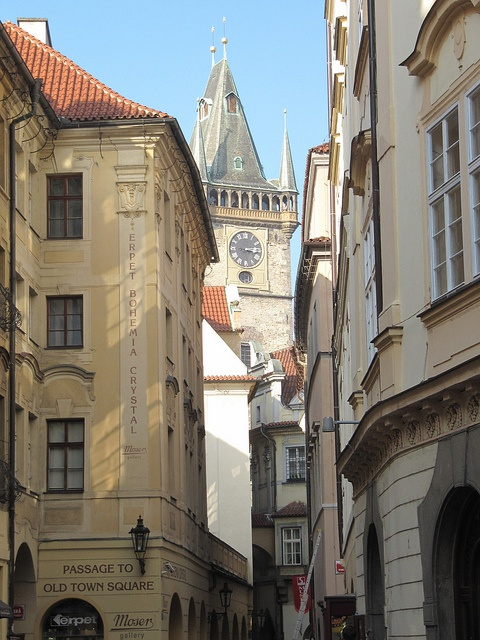Describe the objects in this image and their specific colors. I can see a clock in lightblue, darkgray, lightgray, and gray tones in this image. 